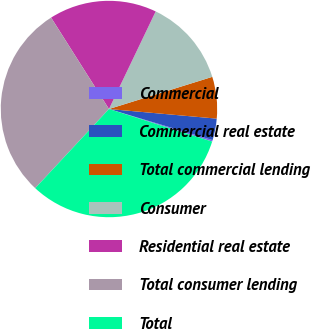Convert chart to OTSL. <chart><loc_0><loc_0><loc_500><loc_500><pie_chart><fcel>Commercial<fcel>Commercial real estate<fcel>Total commercial lending<fcel>Consumer<fcel>Residential real estate<fcel>Total consumer lending<fcel>Total<nl><fcel>0.23%<fcel>3.22%<fcel>6.22%<fcel>13.09%<fcel>16.09%<fcel>29.08%<fcel>32.07%<nl></chart> 